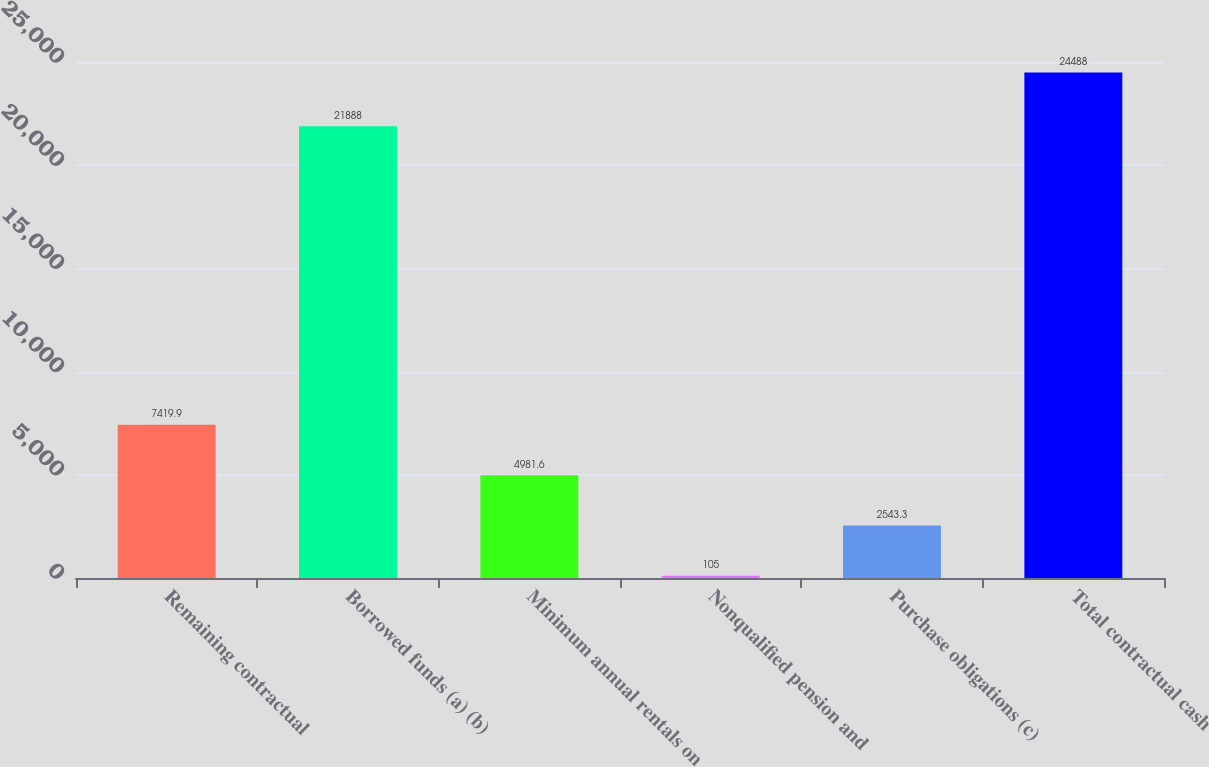Convert chart. <chart><loc_0><loc_0><loc_500><loc_500><bar_chart><fcel>Remaining contractual<fcel>Borrowed funds (a) (b)<fcel>Minimum annual rentals on<fcel>Nonqualified pension and<fcel>Purchase obligations (c)<fcel>Total contractual cash<nl><fcel>7419.9<fcel>21888<fcel>4981.6<fcel>105<fcel>2543.3<fcel>24488<nl></chart> 